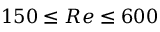<formula> <loc_0><loc_0><loc_500><loc_500>1 5 0 \leq R e \leq 6 0 0</formula> 